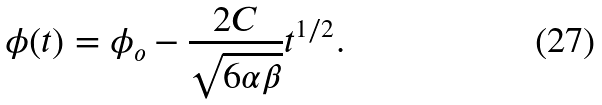<formula> <loc_0><loc_0><loc_500><loc_500>\phi ( t ) = \phi _ { o } - \frac { 2 C } { \sqrt { 6 \alpha \beta } } t ^ { 1 / 2 } .</formula> 